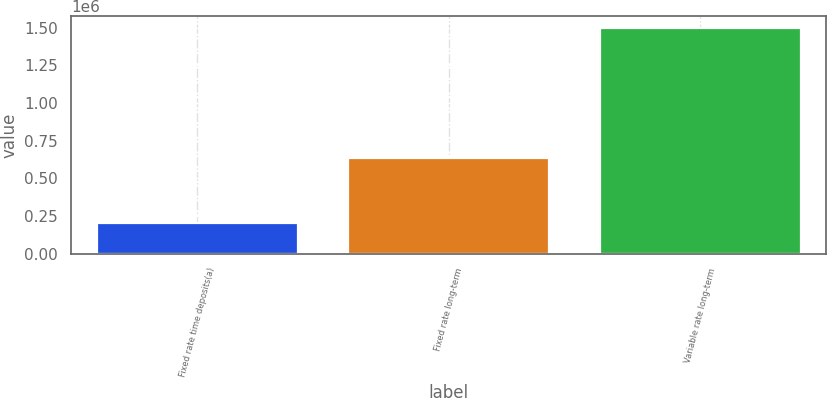Convert chart to OTSL. <chart><loc_0><loc_0><loc_500><loc_500><bar_chart><fcel>Fixed rate time deposits(a)<fcel>Fixed rate long-term<fcel>Variable rate long-term<nl><fcel>205000<fcel>637241<fcel>1.5e+06<nl></chart> 